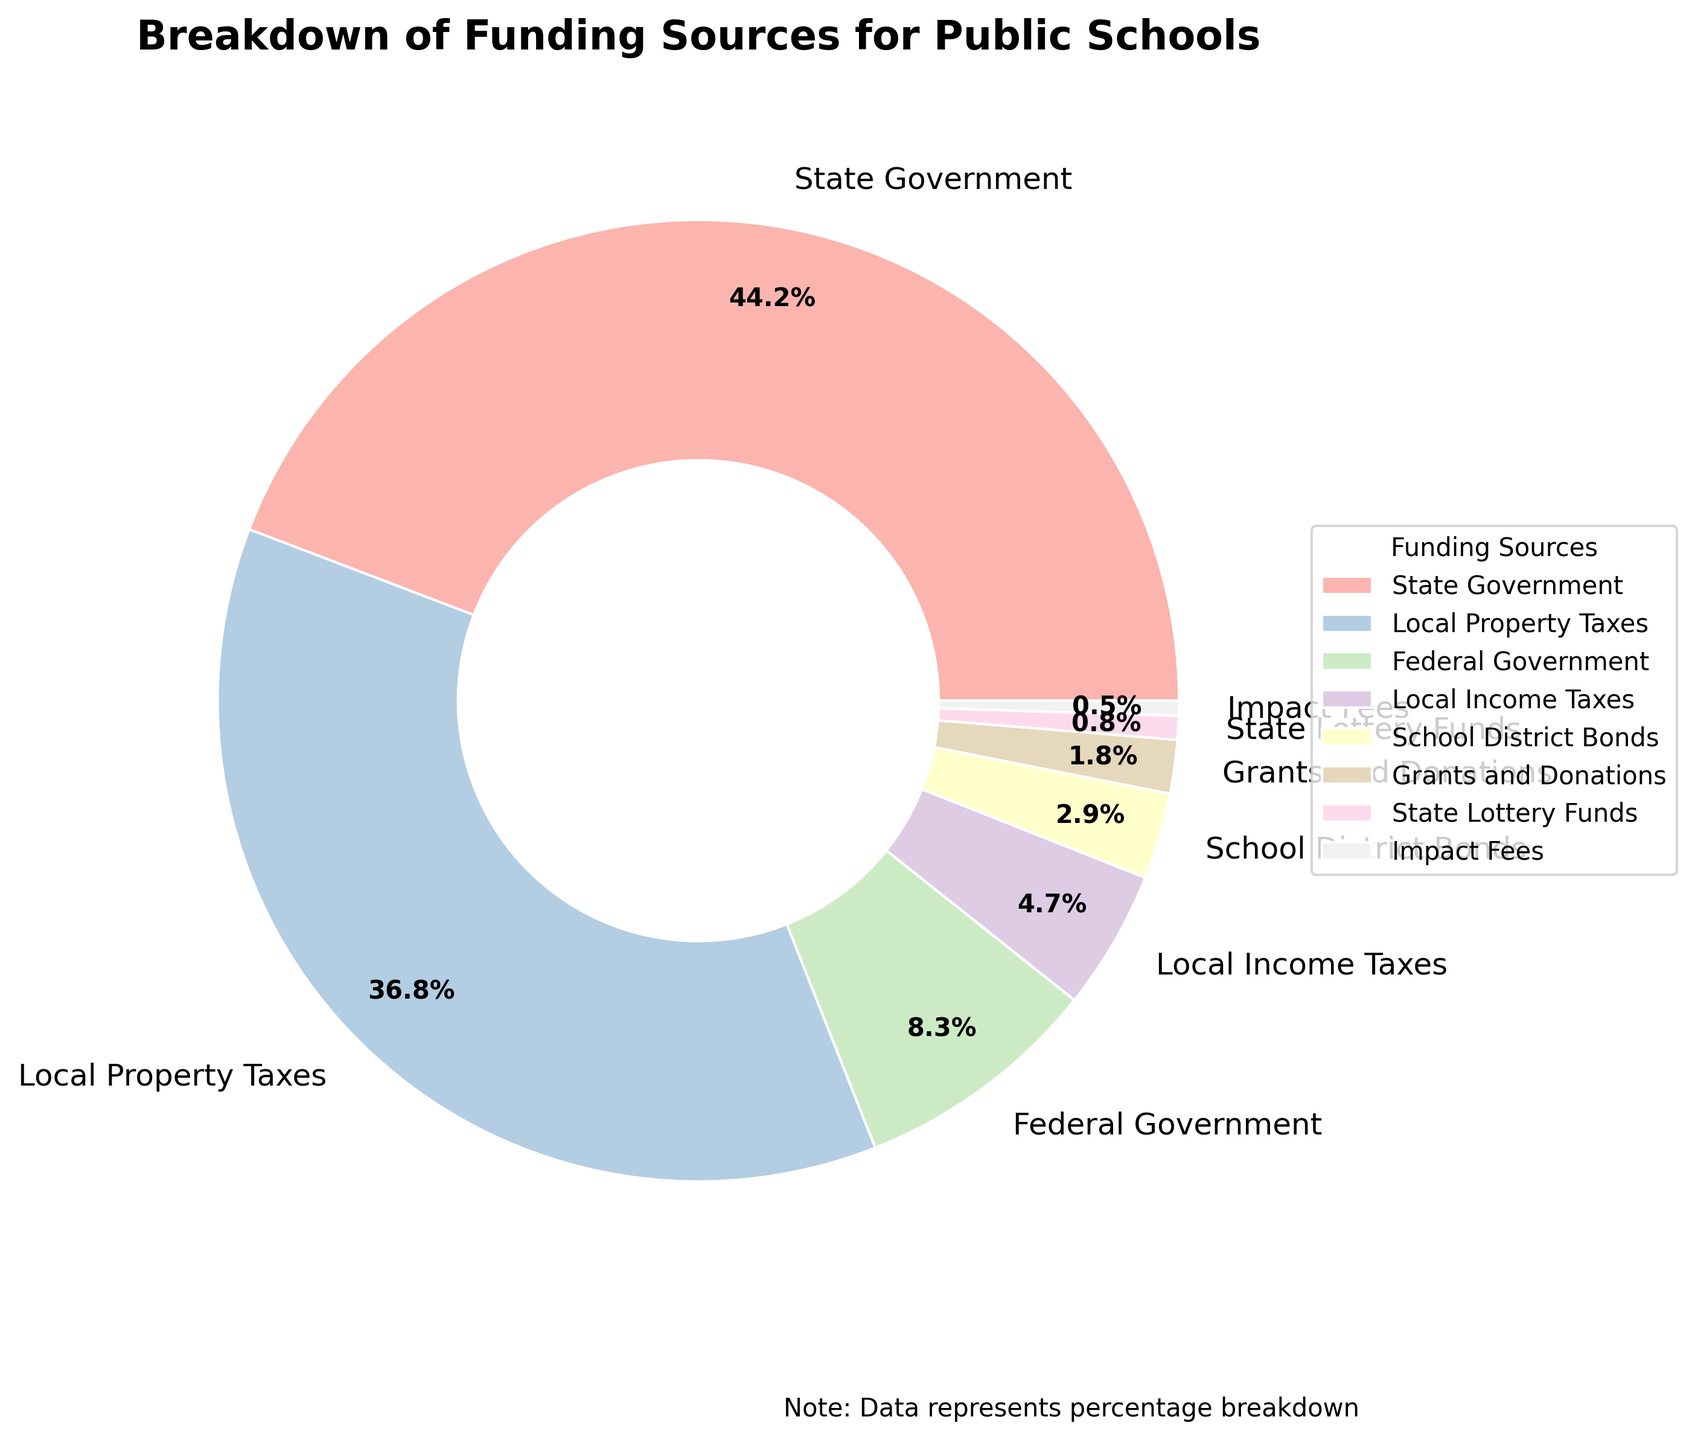What is the largest funding source for public schools? From the pie chart, the label with the largest percentage is the "State Government." This indicates the largest funding source.
Answer: State Government What is the combined percentage of funding from federal sources (Federal Government) and local property taxes? The Federal Government contributes 8.3% and Local Property Taxes contribute 36.8%. Adding these together gives 8.3 + 36.8 = 45.1%.
Answer: 45.1% Which funding source contributes the least, and what is its percentage? From the pie chart, "Impact Fees" has the smallest slice, with a percentage of 0.5%.
Answer: Impact Fees, 0.5% By how much does state government funding exceed federal government funding? State Government funding is 44.2% and Federal Government funding is 8.3%. The difference is 44.2 - 8.3 = 35.9%.
Answer: 35.9% What percentage of the funding is contributed by sources other than the state and local property taxes combined? The combined contribution of State Government and Local Property Taxes is 44.2 + 36.8 = 81%. Therefore, the remaining percentage from other sources is 100 - 81 = 19%.
Answer: 19% Compare the contributions from Local Income Taxes and School District Bonds. Which is greater and by how much? Local Income Taxes contribute 4.7% and School District Bonds contribute 2.9%. The difference is 4.7 - 2.9 = 1.8%. Thus, Local Income Taxes contribute more.
Answer: Local Income Taxes, 1.8% Is the contribution from Grants and Donations more than twice the contribution from State Lottery Funds? Grants and Donations contribute 1.8% whereas State Lottery Funds contribute 0.8%. Twice the contribution from State Lottery Funds is 0.8 * 2 = 1.6%. Since 1.8% is more than 1.6%, Grants and Donations contribute more than twice.
Answer: Yes If we combine all local funding sources (Local Property Taxes and Local Income Taxes), what percentage of the total funding do they represent? The Local Property Taxes contribution is 36.8% and Local Income Taxes is 4.7%. Adding these gives 36.8 + 4.7 = 41.5%.
Answer: 41.5% What is the second smallest funding source and what is its percentage? The second smallest slice after "Impact Fees" (0.5%) is "State Lottery Funds," which contributes 0.8%.
Answer: State Lottery Funds, 0.8% How does the funding contribution of Local Income Taxes compare to that of Local Property Taxes? Local Income Taxes contribute 4.7%, while Local Property Taxes contribute 36.8%. Local Property Taxes contribute more than Local Income Taxes.
Answer: Local Property Taxes contribute more 